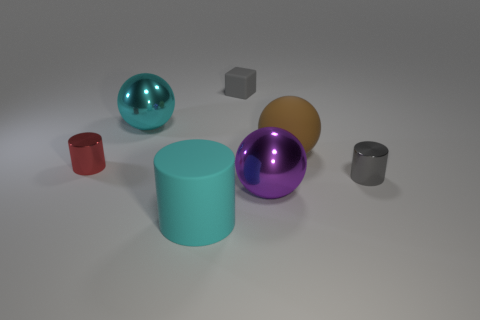Subtract all tiny shiny cylinders. How many cylinders are left? 1 Subtract 1 cylinders. How many cylinders are left? 2 Add 1 yellow shiny cylinders. How many objects exist? 8 Subtract all spheres. How many objects are left? 4 Subtract 0 green balls. How many objects are left? 7 Subtract all small red metal cylinders. Subtract all red rubber cubes. How many objects are left? 6 Add 6 large cyan shiny balls. How many large cyan shiny balls are left? 7 Add 7 tiny gray matte cylinders. How many tiny gray matte cylinders exist? 7 